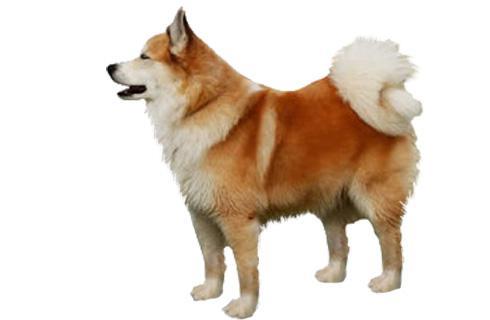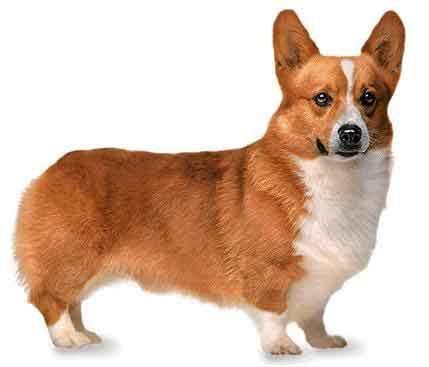The first image is the image on the left, the second image is the image on the right. Given the left and right images, does the statement "In one of the images, a dog can be seen wearing a collar." hold true? Answer yes or no. No. The first image is the image on the left, the second image is the image on the right. Given the left and right images, does the statement "In at least one of the photos, a dog's body is facing left." hold true? Answer yes or no. Yes. 